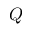<formula> <loc_0><loc_0><loc_500><loc_500>Q</formula> 